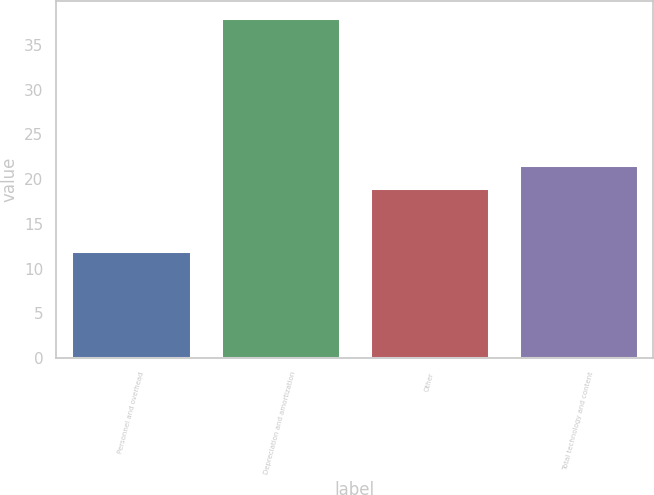<chart> <loc_0><loc_0><loc_500><loc_500><bar_chart><fcel>Personnel and overhead<fcel>Depreciation and amortization<fcel>Other<fcel>Total technology and content<nl><fcel>12<fcel>38<fcel>19<fcel>21.6<nl></chart> 